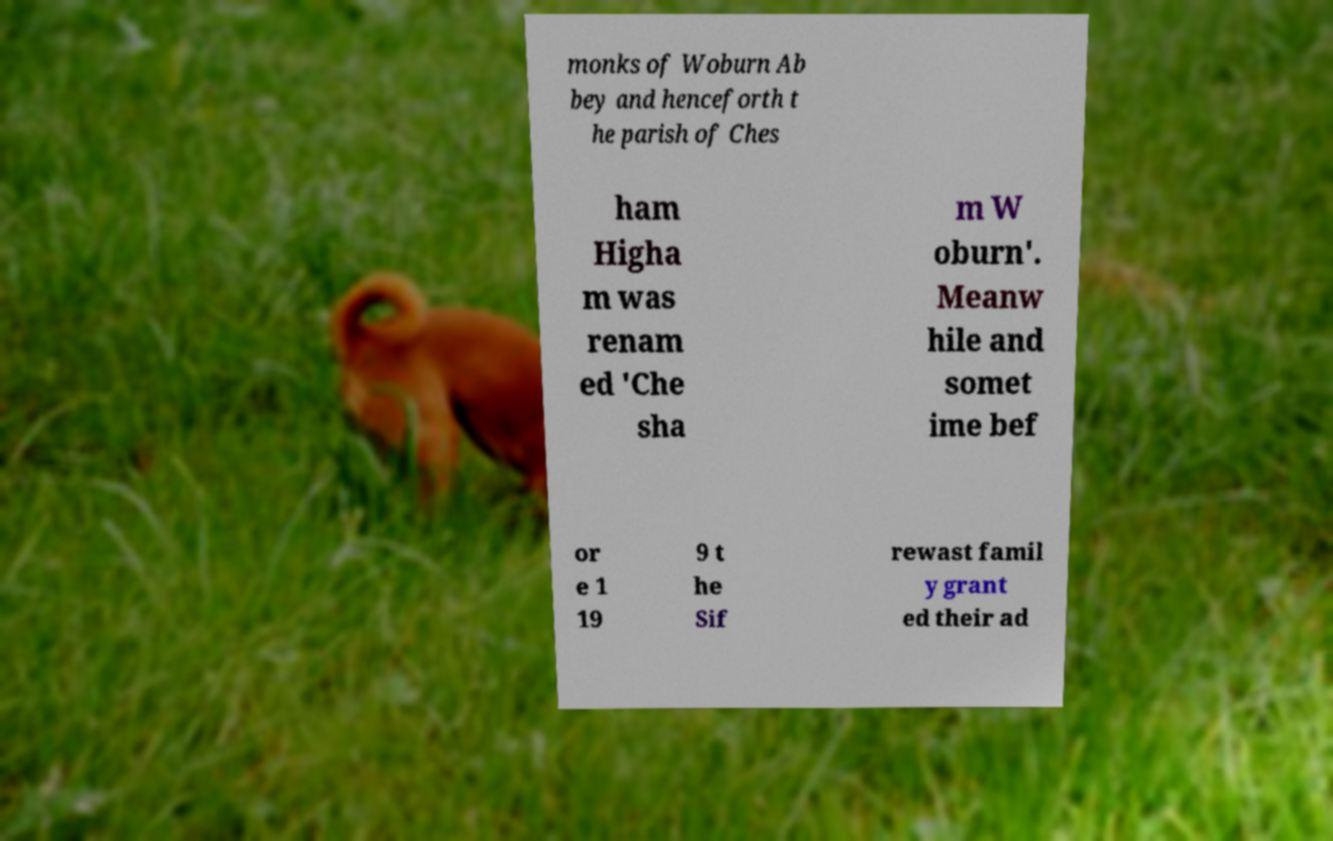I need the written content from this picture converted into text. Can you do that? monks of Woburn Ab bey and henceforth t he parish of Ches ham Higha m was renam ed 'Che sha m W oburn'. Meanw hile and somet ime bef or e 1 19 9 t he Sif rewast famil y grant ed their ad 